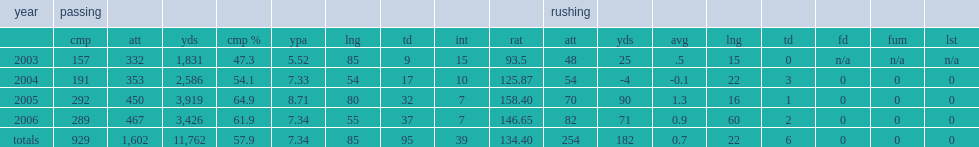What the result did quinn finish the 2006 season with a passing efficiency rating of? 146.65. 